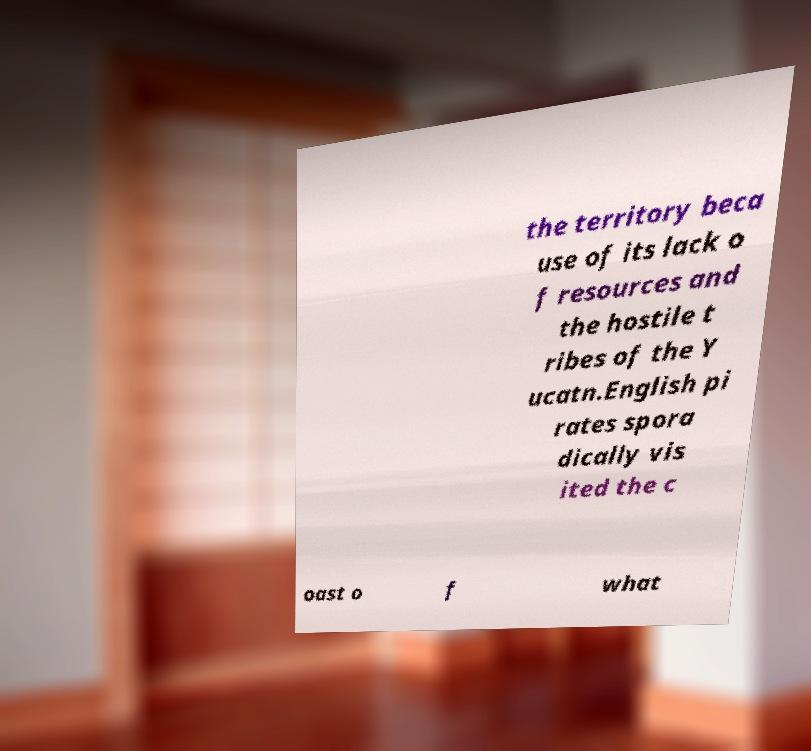Please read and relay the text visible in this image. What does it say? the territory beca use of its lack o f resources and the hostile t ribes of the Y ucatn.English pi rates spora dically vis ited the c oast o f what 